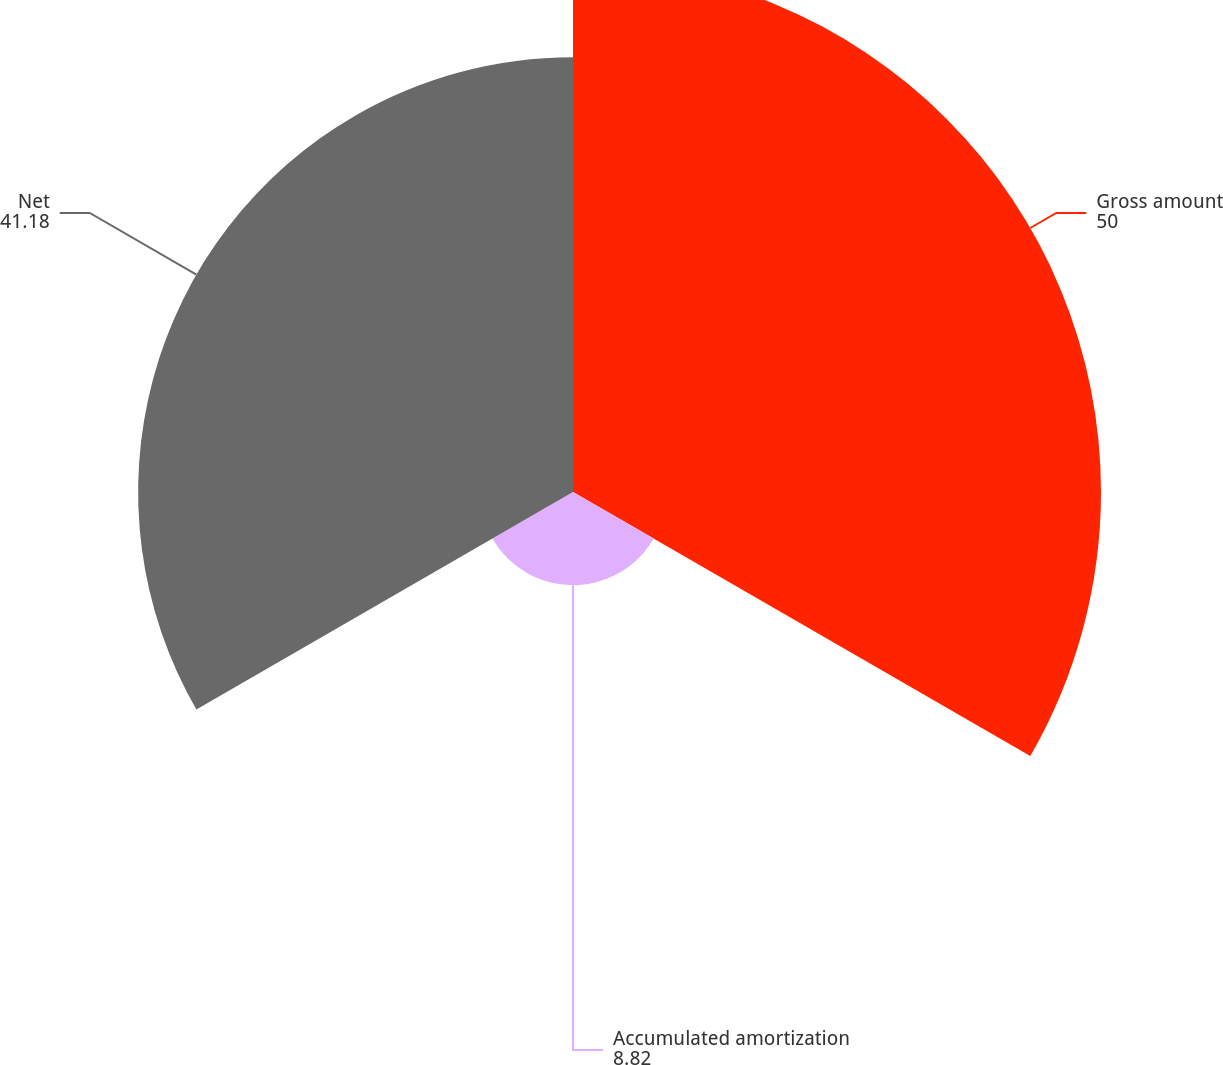<chart> <loc_0><loc_0><loc_500><loc_500><pie_chart><fcel>Gross amount<fcel>Accumulated amortization<fcel>Net<nl><fcel>50.0%<fcel>8.82%<fcel>41.18%<nl></chart> 